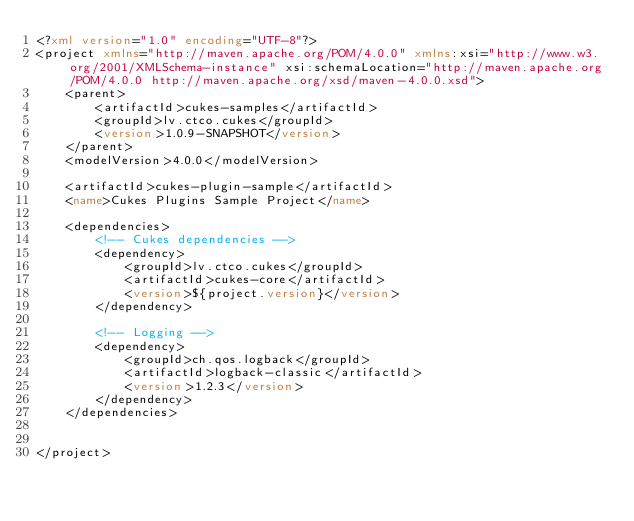Convert code to text. <code><loc_0><loc_0><loc_500><loc_500><_XML_><?xml version="1.0" encoding="UTF-8"?>
<project xmlns="http://maven.apache.org/POM/4.0.0" xmlns:xsi="http://www.w3.org/2001/XMLSchema-instance" xsi:schemaLocation="http://maven.apache.org/POM/4.0.0 http://maven.apache.org/xsd/maven-4.0.0.xsd">
    <parent>
        <artifactId>cukes-samples</artifactId>
        <groupId>lv.ctco.cukes</groupId>
        <version>1.0.9-SNAPSHOT</version>
    </parent>
    <modelVersion>4.0.0</modelVersion>

    <artifactId>cukes-plugin-sample</artifactId>
    <name>Cukes Plugins Sample Project</name>

    <dependencies>
        <!-- Cukes dependencies -->
        <dependency>
            <groupId>lv.ctco.cukes</groupId>
            <artifactId>cukes-core</artifactId>
            <version>${project.version}</version>
        </dependency>

        <!-- Logging -->
        <dependency>
            <groupId>ch.qos.logback</groupId>
            <artifactId>logback-classic</artifactId>
            <version>1.2.3</version>
        </dependency>
    </dependencies>


</project>
</code> 